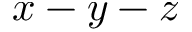Convert formula to latex. <formula><loc_0><loc_0><loc_500><loc_500>x - y - z</formula> 